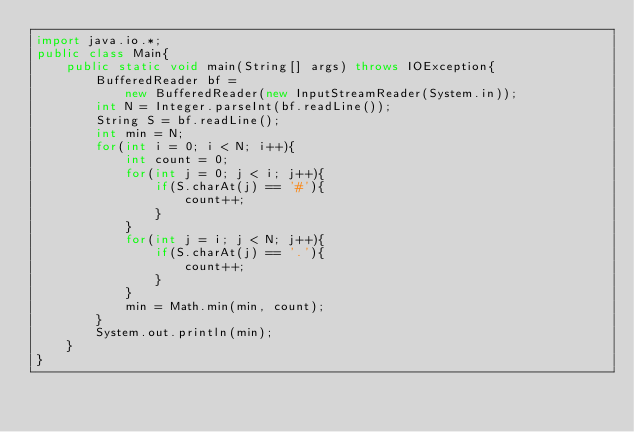Convert code to text. <code><loc_0><loc_0><loc_500><loc_500><_Java_>import java.io.*;
public class Main{
    public static void main(String[] args) throws IOException{
        BufferedReader bf = 
            new BufferedReader(new InputStreamReader(System.in));
        int N = Integer.parseInt(bf.readLine());
        String S = bf.readLine();
        int min = N;
        for(int i = 0; i < N; i++){
            int count = 0;
            for(int j = 0; j < i; j++){
                if(S.charAt(j) == '#'){
                    count++;
                }
            }
            for(int j = i; j < N; j++){
                if(S.charAt(j) == '.'){
                    count++;
                }
            }
            min = Math.min(min, count);
        }
        System.out.println(min);
    }
}</code> 